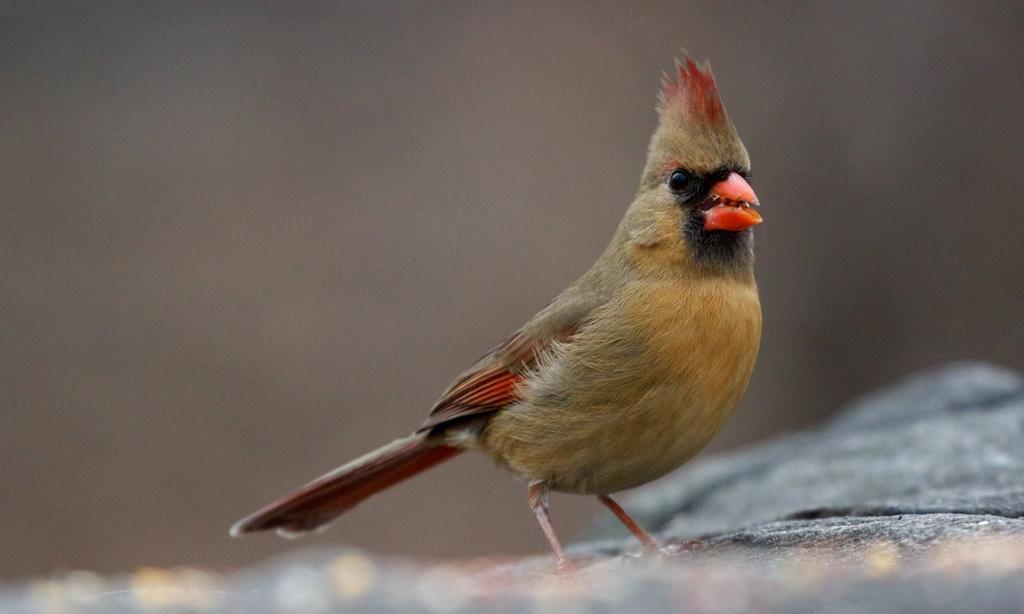Describe this image in one or two sentences. In this picture we can see a bird is standing in the front, there is a blurry background. 